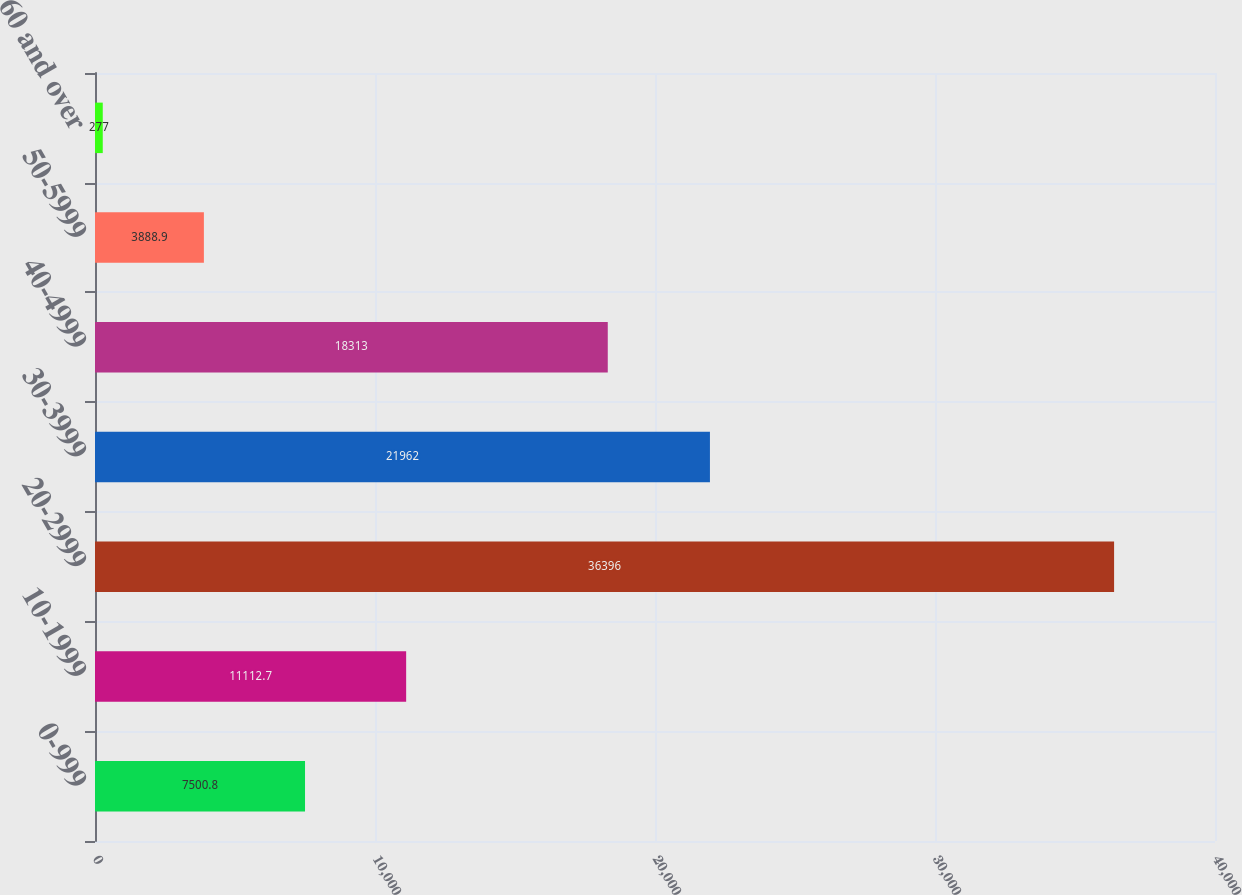<chart> <loc_0><loc_0><loc_500><loc_500><bar_chart><fcel>0-999<fcel>10-1999<fcel>20-2999<fcel>30-3999<fcel>40-4999<fcel>50-5999<fcel>60 and over<nl><fcel>7500.8<fcel>11112.7<fcel>36396<fcel>21962<fcel>18313<fcel>3888.9<fcel>277<nl></chart> 